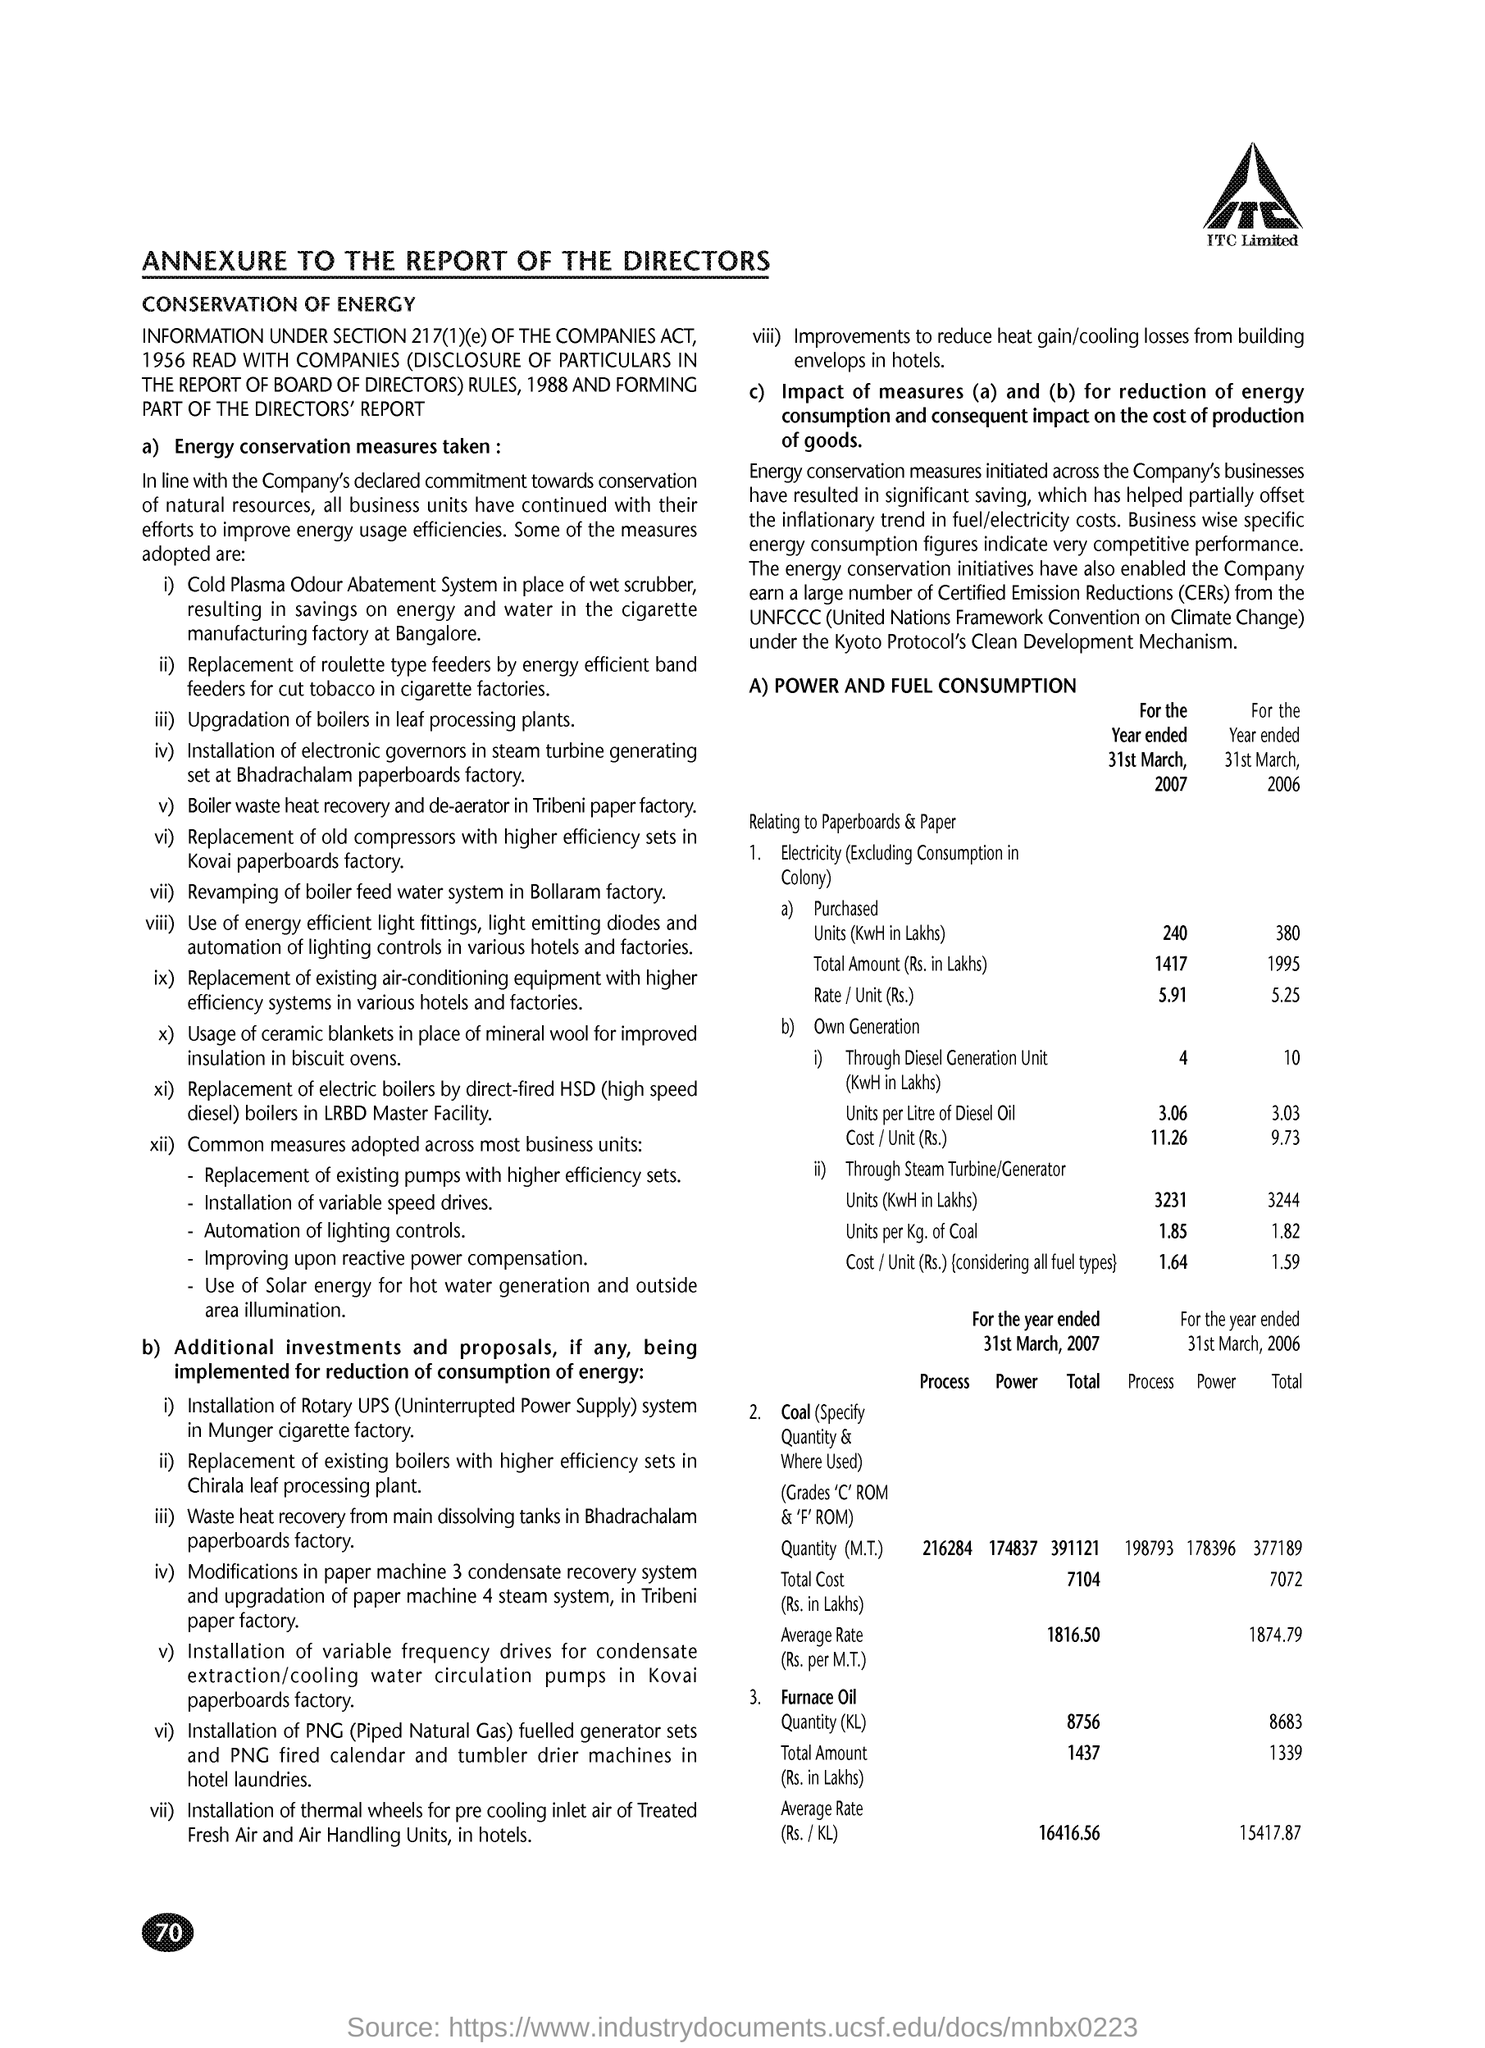Specify some key components in this picture. The page number is 70," the speaker declared. 